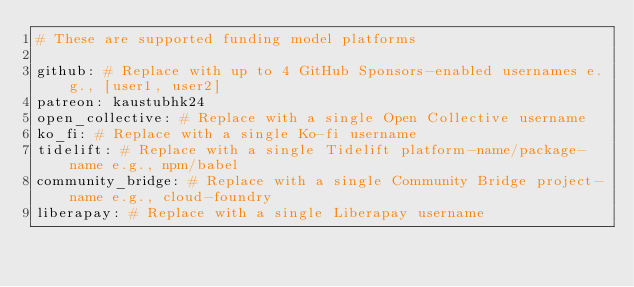Convert code to text. <code><loc_0><loc_0><loc_500><loc_500><_YAML_># These are supported funding model platforms

github: # Replace with up to 4 GitHub Sponsors-enabled usernames e.g., [user1, user2]
patreon: kaustubhk24
open_collective: # Replace with a single Open Collective username
ko_fi: # Replace with a single Ko-fi username
tidelift: # Replace with a single Tidelift platform-name/package-name e.g., npm/babel
community_bridge: # Replace with a single Community Bridge project-name e.g., cloud-foundry
liberapay: # Replace with a single Liberapay username</code> 